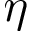Convert formula to latex. <formula><loc_0><loc_0><loc_500><loc_500>\eta</formula> 